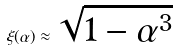<formula> <loc_0><loc_0><loc_500><loc_500>\xi ( \alpha ) \approx { \sqrt { 1 - \alpha ^ { 3 } } }</formula> 